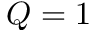Convert formula to latex. <formula><loc_0><loc_0><loc_500><loc_500>Q = 1</formula> 